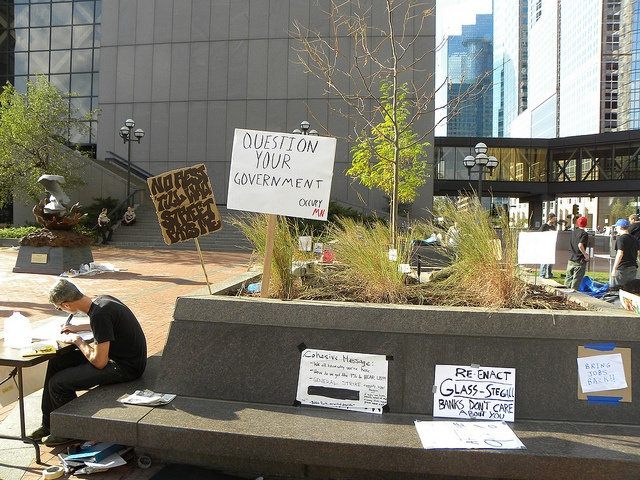Describe the objects in this image and their specific colors. I can see bench in black, gray, and white tones, people in black, gray, ivory, and brown tones, dining table in black, ivory, and tan tones, people in black, gray, ivory, and darkgreen tones, and people in black, gray, darkgray, and beige tones in this image. 